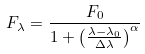<formula> <loc_0><loc_0><loc_500><loc_500>F _ { \lambda } = \frac { F _ { 0 } } { 1 + \left ( \frac { \lambda - \lambda _ { 0 } } { \Delta \lambda } \right ) ^ { \alpha } }</formula> 